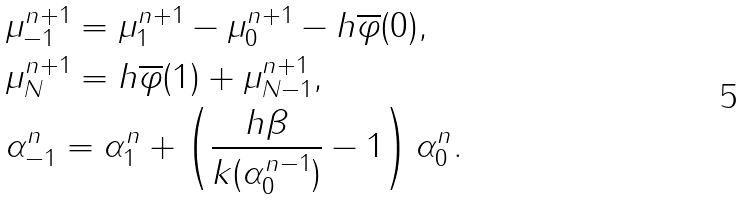Convert formula to latex. <formula><loc_0><loc_0><loc_500><loc_500>& \mu _ { - 1 } ^ { n + 1 } = \mu _ { 1 } ^ { n + 1 } - \mu _ { 0 } ^ { n + 1 } - h \overline { \varphi } ( 0 ) , \\ & \mu _ { N } ^ { n + 1 } = h \overline { \varphi } ( 1 ) + \mu _ { N - 1 } ^ { n + 1 } , \\ & \alpha _ { - 1 } ^ { n } = \alpha _ { 1 } ^ { n } + \left ( \frac { h \beta } { k ( \alpha _ { 0 } ^ { n - 1 } ) } - 1 \right ) \alpha _ { 0 } ^ { n } .</formula> 